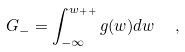Convert formula to latex. <formula><loc_0><loc_0><loc_500><loc_500>G _ { - } = \int _ { - \infty } ^ { w _ { + + } } g ( w ) d w \ \ ,</formula> 